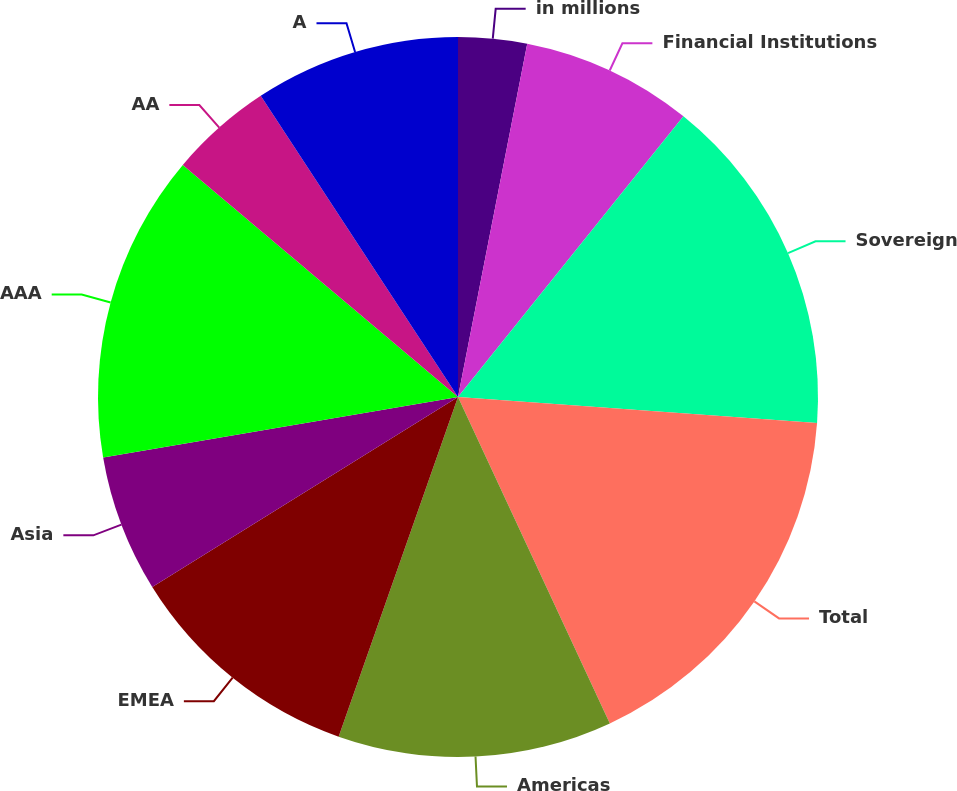Convert chart to OTSL. <chart><loc_0><loc_0><loc_500><loc_500><pie_chart><fcel>in millions<fcel>Financial Institutions<fcel>Sovereign<fcel>Total<fcel>Americas<fcel>EMEA<fcel>Asia<fcel>AAA<fcel>AA<fcel>A<nl><fcel>3.08%<fcel>7.69%<fcel>15.38%<fcel>16.92%<fcel>12.31%<fcel>10.77%<fcel>6.16%<fcel>13.84%<fcel>4.62%<fcel>9.23%<nl></chart> 